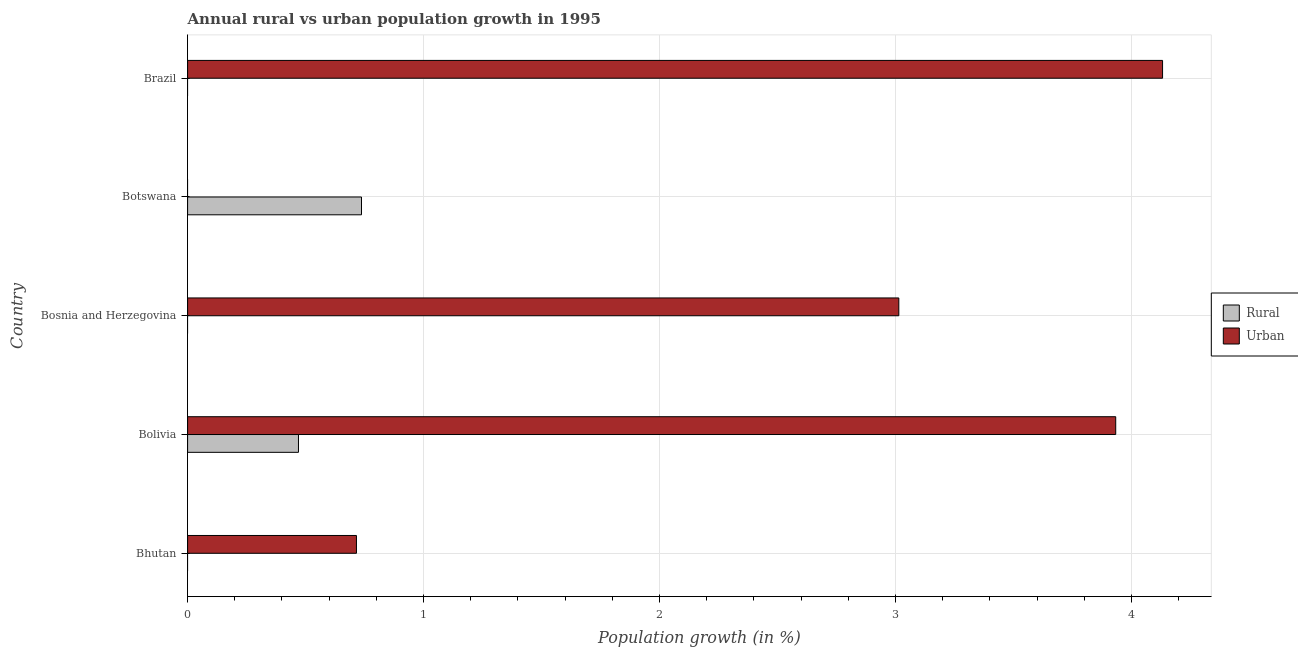Are the number of bars on each tick of the Y-axis equal?
Your answer should be very brief. No. What is the rural population growth in Bosnia and Herzegovina?
Make the answer very short. 0. Across all countries, what is the maximum rural population growth?
Your answer should be very brief. 0.74. What is the total rural population growth in the graph?
Your answer should be very brief. 1.21. What is the difference between the urban population growth in Bolivia and that in Brazil?
Ensure brevity in your answer.  -0.2. What is the difference between the urban population growth in Bhutan and the rural population growth in Bolivia?
Your answer should be very brief. 0.25. What is the average rural population growth per country?
Keep it short and to the point. 0.24. What is the difference between the rural population growth and urban population growth in Bolivia?
Ensure brevity in your answer.  -3.46. In how many countries, is the rural population growth greater than 1.4 %?
Keep it short and to the point. 0. Is the urban population growth in Bhutan less than that in Bosnia and Herzegovina?
Offer a terse response. Yes. What is the difference between the highest and the second highest urban population growth?
Provide a succinct answer. 0.2. What is the difference between the highest and the lowest rural population growth?
Your answer should be compact. 0.74. In how many countries, is the urban population growth greater than the average urban population growth taken over all countries?
Your response must be concise. 3. How many countries are there in the graph?
Give a very brief answer. 5. Are the values on the major ticks of X-axis written in scientific E-notation?
Ensure brevity in your answer.  No. Does the graph contain any zero values?
Make the answer very short. Yes. Does the graph contain grids?
Your answer should be compact. Yes. What is the title of the graph?
Your answer should be very brief. Annual rural vs urban population growth in 1995. Does "Primary income" appear as one of the legend labels in the graph?
Your answer should be very brief. No. What is the label or title of the X-axis?
Make the answer very short. Population growth (in %). What is the label or title of the Y-axis?
Keep it short and to the point. Country. What is the Population growth (in %) in Urban  in Bhutan?
Ensure brevity in your answer.  0.72. What is the Population growth (in %) in Rural in Bolivia?
Your answer should be compact. 0.47. What is the Population growth (in %) in Urban  in Bolivia?
Give a very brief answer. 3.93. What is the Population growth (in %) in Rural in Bosnia and Herzegovina?
Make the answer very short. 0. What is the Population growth (in %) in Urban  in Bosnia and Herzegovina?
Your answer should be very brief. 3.01. What is the Population growth (in %) of Rural in Botswana?
Provide a succinct answer. 0.74. What is the Population growth (in %) of Rural in Brazil?
Your answer should be compact. 0. What is the Population growth (in %) of Urban  in Brazil?
Make the answer very short. 4.13. Across all countries, what is the maximum Population growth (in %) in Rural?
Provide a short and direct response. 0.74. Across all countries, what is the maximum Population growth (in %) in Urban ?
Give a very brief answer. 4.13. Across all countries, what is the minimum Population growth (in %) of Urban ?
Keep it short and to the point. 0. What is the total Population growth (in %) in Rural in the graph?
Offer a terse response. 1.21. What is the total Population growth (in %) in Urban  in the graph?
Offer a terse response. 11.79. What is the difference between the Population growth (in %) in Urban  in Bhutan and that in Bolivia?
Your answer should be compact. -3.22. What is the difference between the Population growth (in %) of Urban  in Bhutan and that in Bosnia and Herzegovina?
Give a very brief answer. -2.3. What is the difference between the Population growth (in %) in Urban  in Bhutan and that in Brazil?
Offer a very short reply. -3.42. What is the difference between the Population growth (in %) in Urban  in Bolivia and that in Bosnia and Herzegovina?
Your response must be concise. 0.92. What is the difference between the Population growth (in %) in Rural in Bolivia and that in Botswana?
Your response must be concise. -0.27. What is the difference between the Population growth (in %) in Urban  in Bolivia and that in Brazil?
Your response must be concise. -0.2. What is the difference between the Population growth (in %) in Urban  in Bosnia and Herzegovina and that in Brazil?
Provide a succinct answer. -1.12. What is the difference between the Population growth (in %) in Rural in Bolivia and the Population growth (in %) in Urban  in Bosnia and Herzegovina?
Give a very brief answer. -2.54. What is the difference between the Population growth (in %) in Rural in Bolivia and the Population growth (in %) in Urban  in Brazil?
Provide a succinct answer. -3.66. What is the difference between the Population growth (in %) in Rural in Botswana and the Population growth (in %) in Urban  in Brazil?
Provide a succinct answer. -3.39. What is the average Population growth (in %) in Rural per country?
Offer a very short reply. 0.24. What is the average Population growth (in %) of Urban  per country?
Give a very brief answer. 2.36. What is the difference between the Population growth (in %) of Rural and Population growth (in %) of Urban  in Bolivia?
Offer a terse response. -3.46. What is the ratio of the Population growth (in %) in Urban  in Bhutan to that in Bolivia?
Provide a short and direct response. 0.18. What is the ratio of the Population growth (in %) of Urban  in Bhutan to that in Bosnia and Herzegovina?
Keep it short and to the point. 0.24. What is the ratio of the Population growth (in %) in Urban  in Bhutan to that in Brazil?
Your answer should be very brief. 0.17. What is the ratio of the Population growth (in %) in Urban  in Bolivia to that in Bosnia and Herzegovina?
Your response must be concise. 1.3. What is the ratio of the Population growth (in %) in Rural in Bolivia to that in Botswana?
Offer a very short reply. 0.64. What is the ratio of the Population growth (in %) of Urban  in Bosnia and Herzegovina to that in Brazil?
Offer a very short reply. 0.73. What is the difference between the highest and the second highest Population growth (in %) of Urban ?
Provide a succinct answer. 0.2. What is the difference between the highest and the lowest Population growth (in %) of Rural?
Offer a very short reply. 0.74. What is the difference between the highest and the lowest Population growth (in %) of Urban ?
Provide a succinct answer. 4.13. 